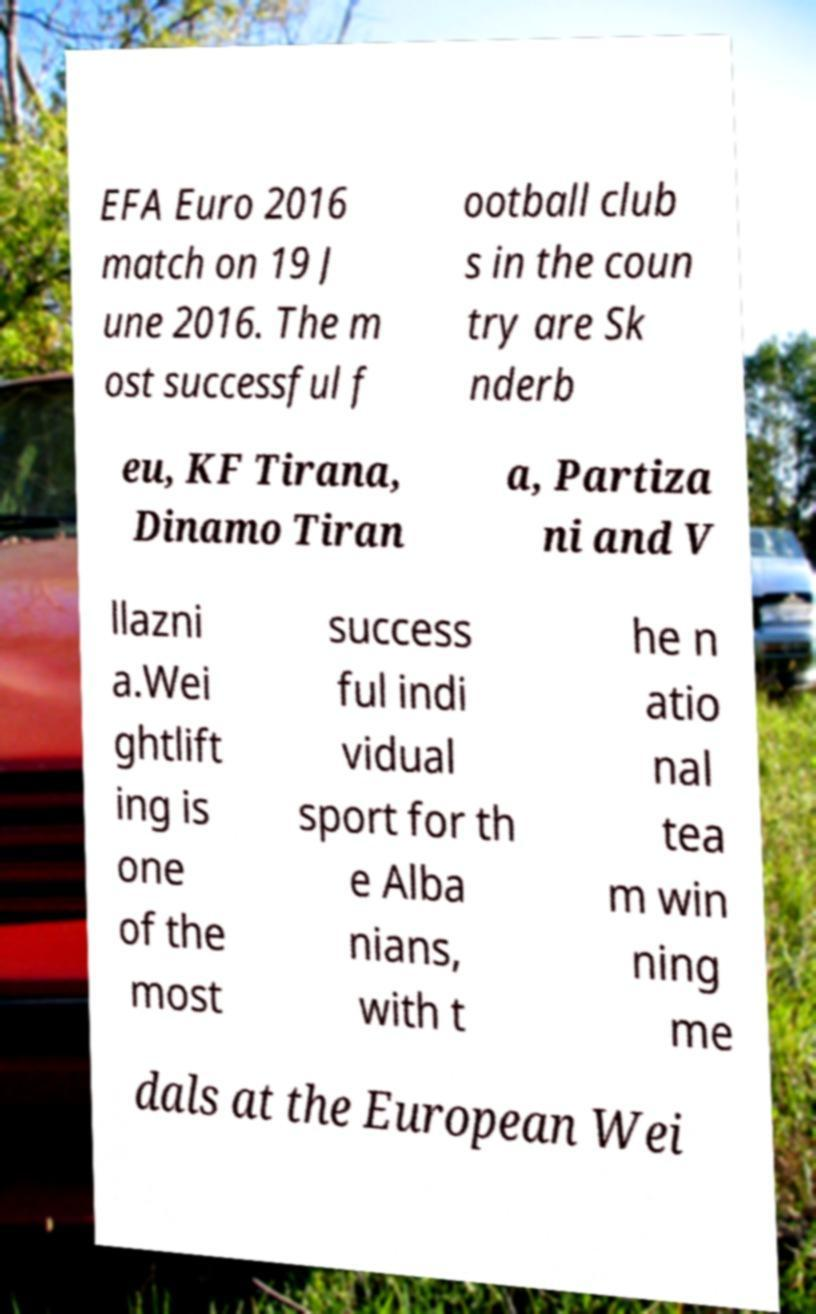There's text embedded in this image that I need extracted. Can you transcribe it verbatim? EFA Euro 2016 match on 19 J une 2016. The m ost successful f ootball club s in the coun try are Sk nderb eu, KF Tirana, Dinamo Tiran a, Partiza ni and V llazni a.Wei ghtlift ing is one of the most success ful indi vidual sport for th e Alba nians, with t he n atio nal tea m win ning me dals at the European Wei 